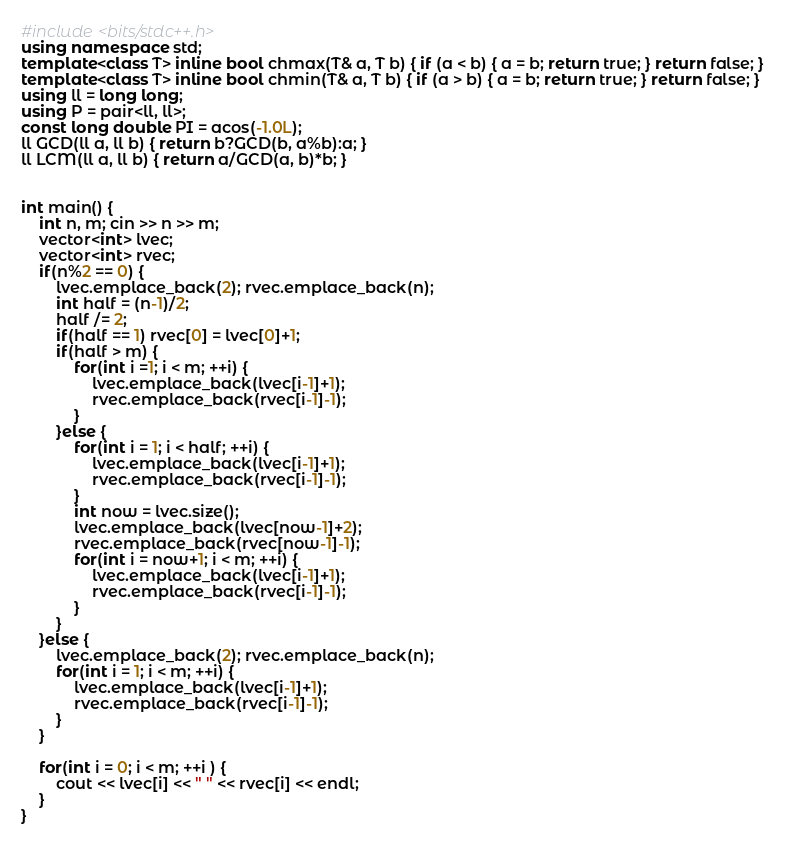<code> <loc_0><loc_0><loc_500><loc_500><_C++_>#include <bits/stdc++.h>
using namespace std;
template<class T> inline bool chmax(T& a, T b) { if (a < b) { a = b; return true; } return false; }
template<class T> inline bool chmin(T& a, T b) { if (a > b) { a = b; return true; } return false; }
using ll = long long;
using P = pair<ll, ll>;
const long double PI = acos(-1.0L);
ll GCD(ll a, ll b) { return b?GCD(b, a%b):a; }
ll LCM(ll a, ll b) { return a/GCD(a, b)*b; }


int main() {
    int n, m; cin >> n >> m;
    vector<int> lvec;
    vector<int> rvec;
    if(n%2 == 0) {
        lvec.emplace_back(2); rvec.emplace_back(n);
        int half = (n-1)/2;
        half /= 2;
        if(half == 1) rvec[0] = lvec[0]+1;
        if(half > m) {
            for(int i =1; i < m; ++i) {
                lvec.emplace_back(lvec[i-1]+1);
                rvec.emplace_back(rvec[i-1]-1);
            }
        }else {
            for(int i = 1; i < half; ++i) {
                lvec.emplace_back(lvec[i-1]+1);
                rvec.emplace_back(rvec[i-1]-1);
            }
            int now = lvec.size();
            lvec.emplace_back(lvec[now-1]+2);
            rvec.emplace_back(rvec[now-1]-1);
            for(int i = now+1; i < m; ++i) {
                lvec.emplace_back(lvec[i-1]+1);
                rvec.emplace_back(rvec[i-1]-1);
            }
        }
    }else {
        lvec.emplace_back(2); rvec.emplace_back(n);
        for(int i = 1; i < m; ++i) {
            lvec.emplace_back(lvec[i-1]+1);
            rvec.emplace_back(rvec[i-1]-1);
        }
    }

    for(int i = 0; i < m; ++i ) {
        cout << lvec[i] << " " << rvec[i] << endl;
    }
}</code> 